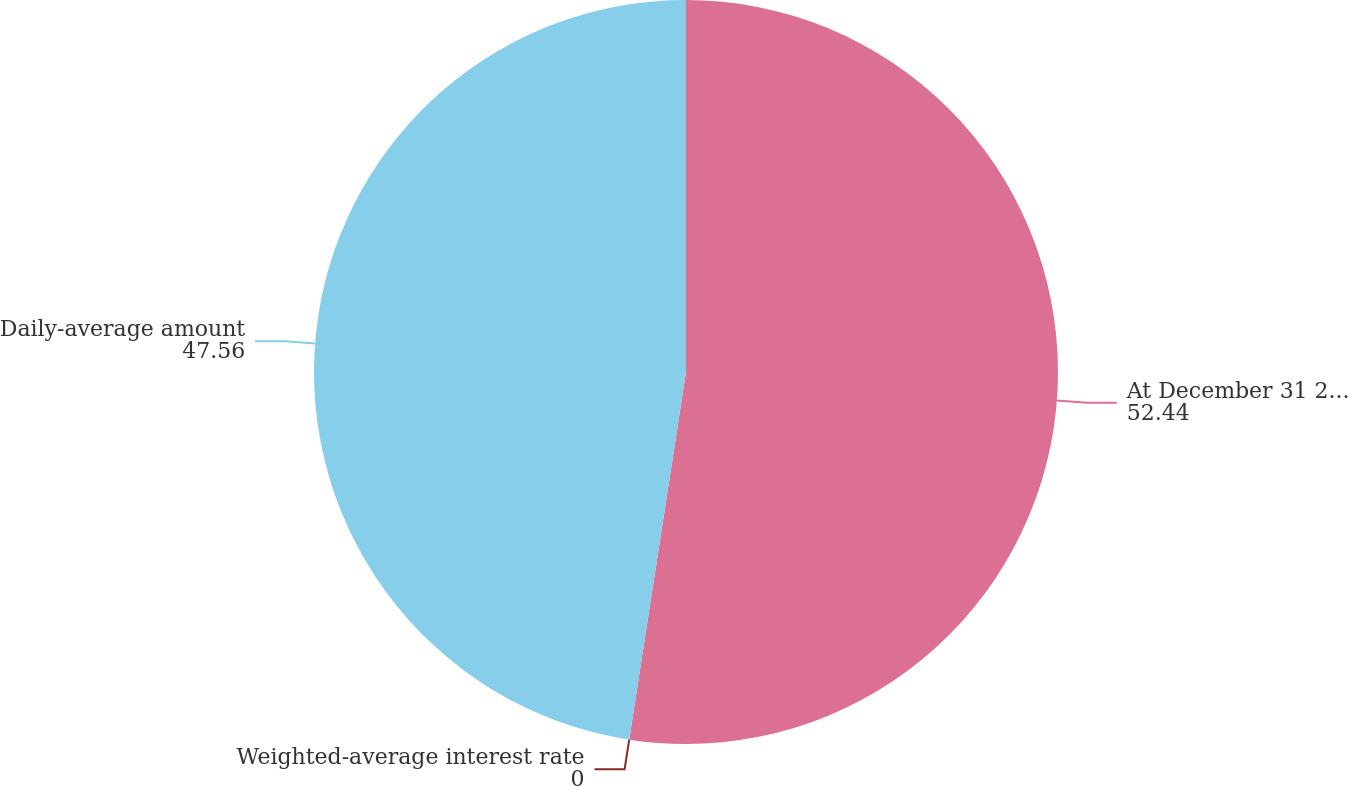Convert chart to OTSL. <chart><loc_0><loc_0><loc_500><loc_500><pie_chart><fcel>At December 31 2003 Amount<fcel>Weighted-average interest rate<fcel>Daily-average amount<nl><fcel>52.44%<fcel>0.0%<fcel>47.56%<nl></chart> 